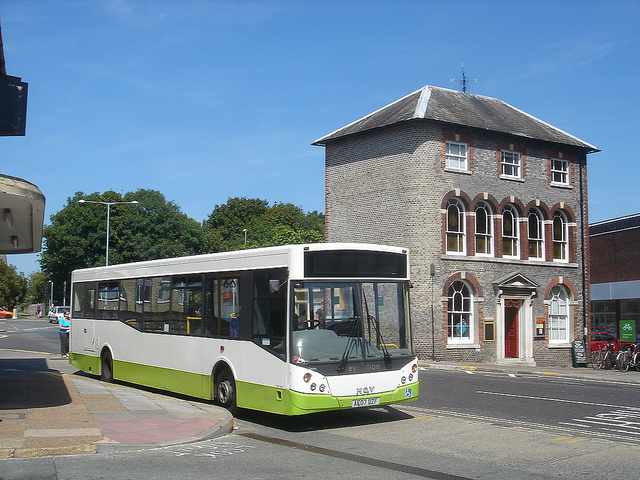Identify and read out the text in this image. ROV 